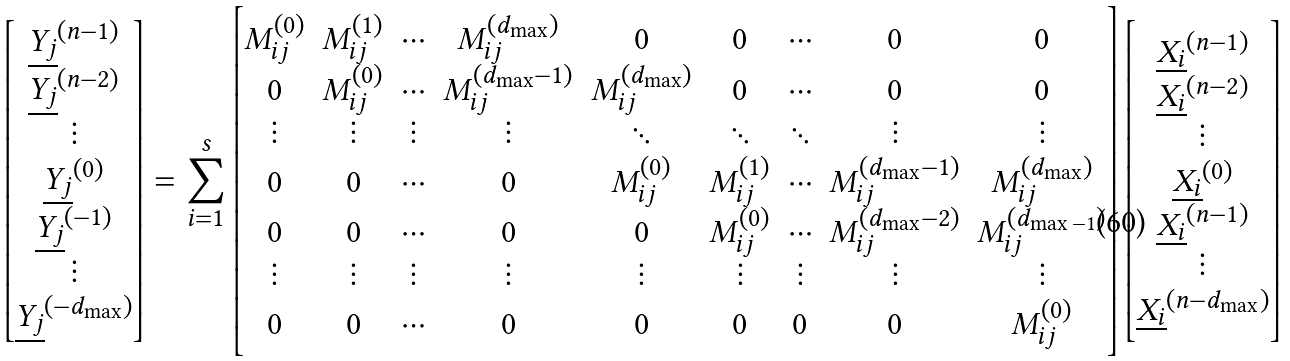<formula> <loc_0><loc_0><loc_500><loc_500>\begin{bmatrix} \underline { Y _ { j } } ^ { ( n - 1 ) } \\ \underline { Y _ { j } } ^ { ( n - 2 ) } \\ \vdots \\ \underline { Y _ { j } } ^ { ( 0 ) } \\ \underline { Y _ { j } } ^ { ( - 1 ) } \\ \vdots \\ \underline { Y _ { j } } ^ { ( - d _ { \max } ) } \\ \end{bmatrix} = \sum _ { i = 1 } ^ { s } \begin{bmatrix} M _ { i j } ^ { ( 0 ) } & M _ { i j } ^ { ( 1 ) } & \cdots & M _ { i j } ^ { ( d _ { \max } ) } & 0 & 0 & \cdots & 0 & 0 \\ 0 & M _ { i j } ^ { ( 0 ) } & \cdots & M _ { i j } ^ { ( d _ { \max } - 1 ) } & M _ { i j } ^ { ( d _ { \max } ) } & 0 & \cdots & 0 & 0 \\ \vdots & \vdots & \vdots & \vdots & \ddots & \ddots & \ddots & \vdots & \vdots \\ 0 & 0 & \cdots & 0 & M _ { i j } ^ { ( 0 ) } & M _ { i j } ^ { ( 1 ) } & \cdots & M _ { i j } ^ { ( d _ { \max } - 1 ) } & M _ { i j } ^ { ( d _ { \max } ) } \\ 0 & 0 & \cdots & 0 & 0 & M _ { i j } ^ { ( 0 ) } & \cdots & M _ { i j } ^ { ( d _ { \max } - 2 ) } & M _ { i j } ^ { ( d _ { \max - 1 } ) } \\ \vdots & \vdots & \vdots & \vdots & \vdots & \vdots & \vdots & \vdots & \vdots \\ 0 & 0 & \cdots & 0 & 0 & 0 & 0 & 0 & M _ { i j } ^ { ( 0 ) } \\ \end{bmatrix} \begin{bmatrix} \underline { X _ { i } } ^ { ( n - 1 ) } \\ \underline { X _ { i } } ^ { ( n - 2 ) } \\ \vdots \\ \underline { X _ { i } } ^ { ( 0 ) } \\ \underline { X _ { i } } ^ { ( n - 1 ) } \\ \vdots \\ \underline { X _ { i } } ^ { ( n - d _ { \max } ) } \\ \end{bmatrix}</formula> 